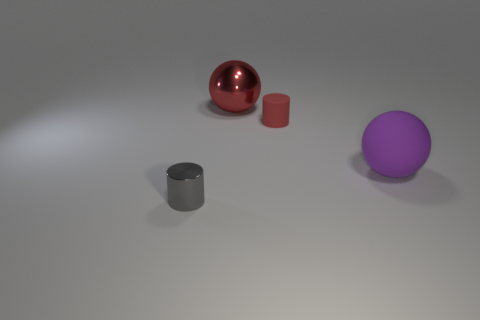Is the size of the red shiny ball that is to the left of the big purple sphere the same as the rubber thing that is on the left side of the purple rubber object?
Ensure brevity in your answer.  No. What number of large green cylinders are there?
Your answer should be compact. 0. There is a sphere that is right of the big ball that is left of the purple object that is in front of the large red metallic object; how big is it?
Provide a short and direct response. Large. Does the large metal sphere have the same color as the small rubber object?
Offer a very short reply. Yes. There is a small matte object; what number of big rubber spheres are in front of it?
Your answer should be compact. 1. Are there the same number of cylinders that are to the right of the small rubber cylinder and large green metallic balls?
Your answer should be very brief. Yes. How many objects are either red cylinders or metal objects?
Your answer should be compact. 3. What is the shape of the tiny thing behind the tiny thing in front of the small red rubber cylinder?
Make the answer very short. Cylinder. What is the shape of the purple object that is made of the same material as the red cylinder?
Offer a very short reply. Sphere. What is the size of the ball to the right of the shiny thing that is behind the large purple ball?
Ensure brevity in your answer.  Large. 